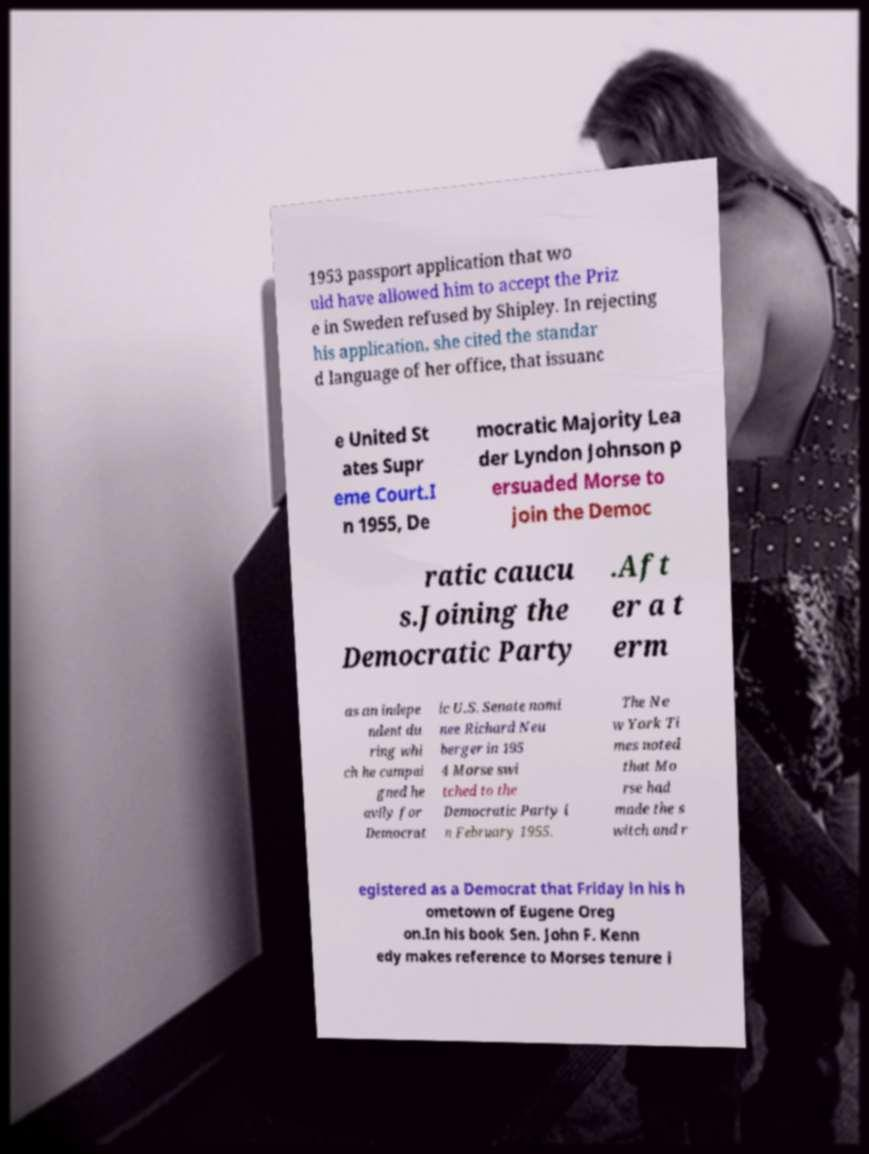Can you read and provide the text displayed in the image?This photo seems to have some interesting text. Can you extract and type it out for me? 1953 passport application that wo uld have allowed him to accept the Priz e in Sweden refused by Shipley. In rejecting his application, she cited the standar d language of her office, that issuanc e United St ates Supr eme Court.I n 1955, De mocratic Majority Lea der Lyndon Johnson p ersuaded Morse to join the Democ ratic caucu s.Joining the Democratic Party .Aft er a t erm as an indepe ndent du ring whi ch he campai gned he avily for Democrat ic U.S. Senate nomi nee Richard Neu berger in 195 4 Morse swi tched to the Democratic Party i n February 1955. The Ne w York Ti mes noted that Mo rse had made the s witch and r egistered as a Democrat that Friday in his h ometown of Eugene Oreg on.In his book Sen. John F. Kenn edy makes reference to Morses tenure i 